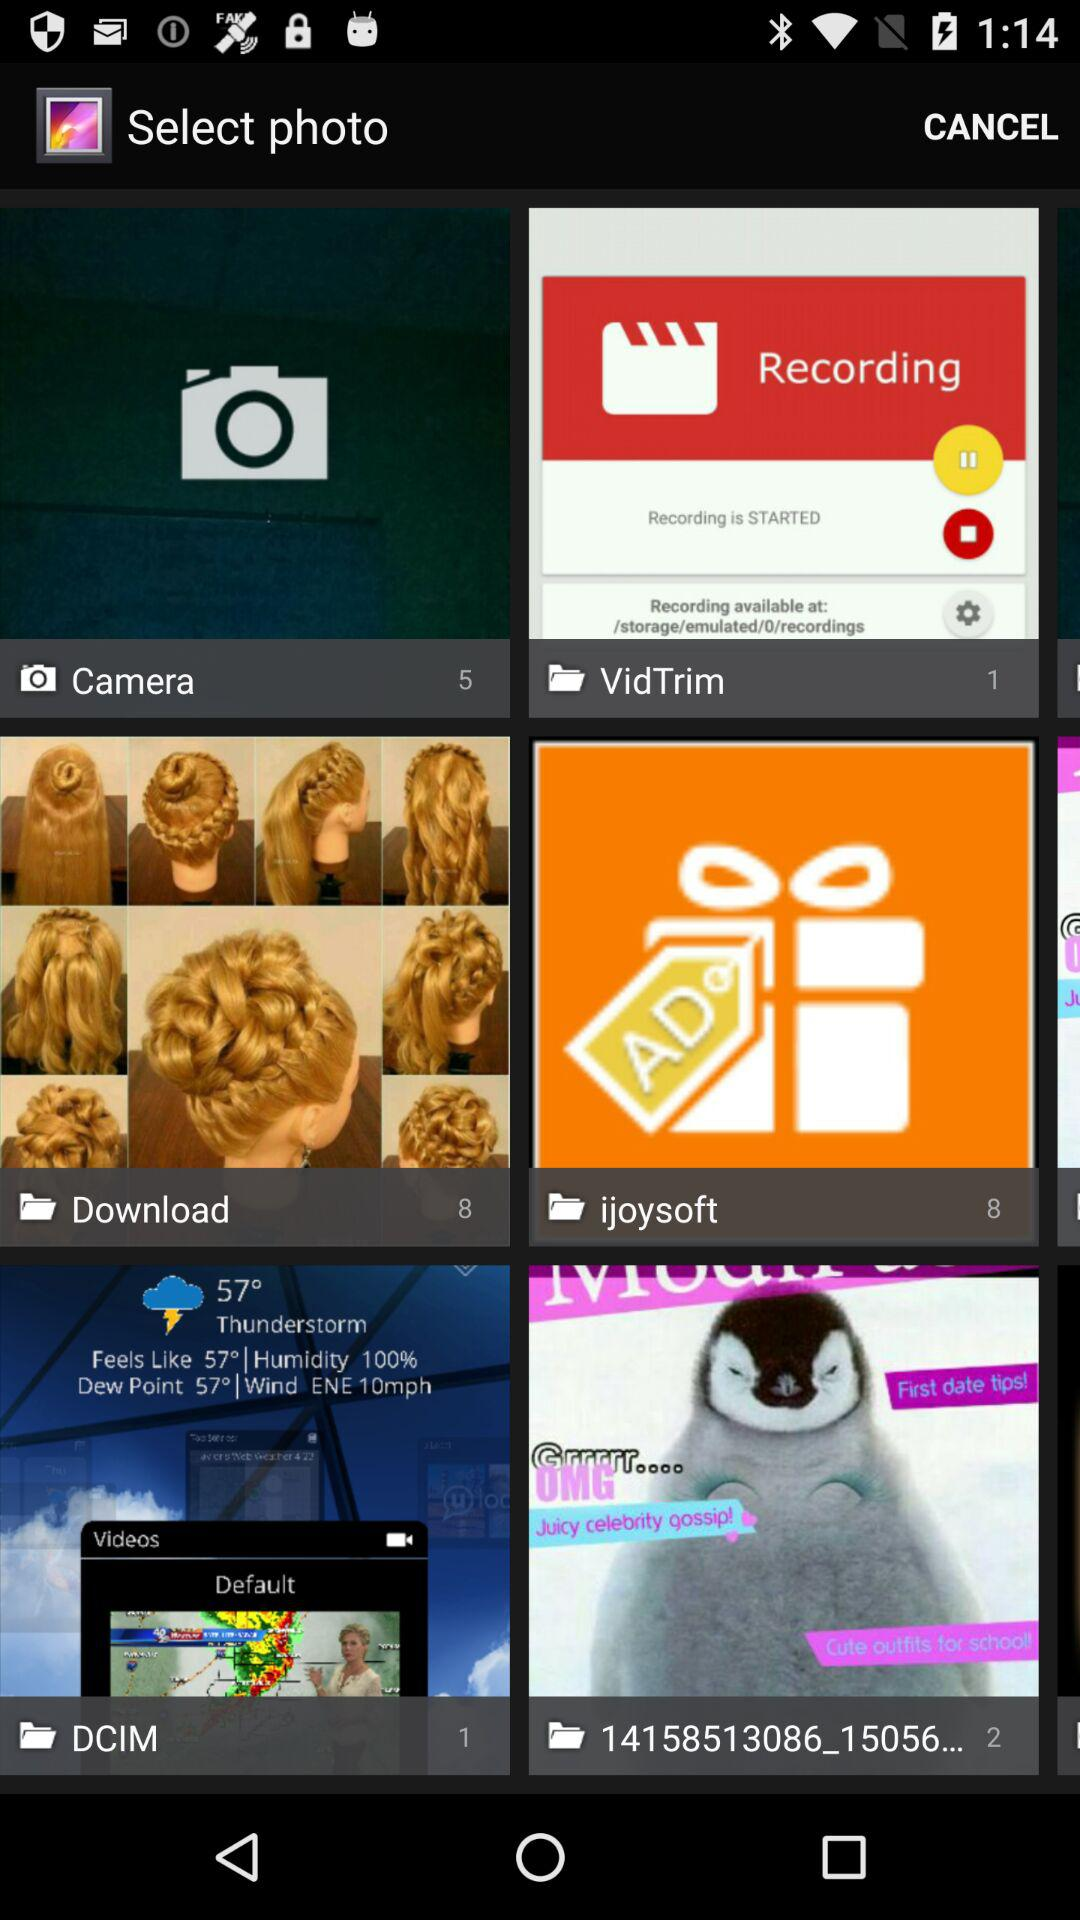How many photos are there in "Camera" folder? There are 5 photos. 